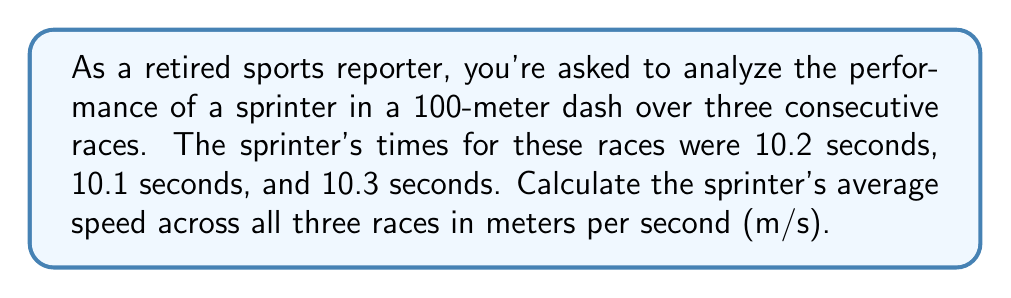What is the answer to this math problem? To solve this problem, we'll follow these steps:

1) First, we need to calculate the speed for each individual race:
   Speed = Distance / Time

   For a 100-meter dash:
   $$\text{Speed} = \frac{100 \text{ meters}}{\text{Time in seconds}}$$

   Race 1: $\frac{100}{10.2} = 9.80$ m/s
   Race 2: $\frac{100}{10.1} = 9.90$ m/s
   Race 3: $\frac{100}{10.3} = 9.71$ m/s

2) Now, to find the average speed, we sum up all the speeds and divide by the number of races:

   $$\text{Average Speed} = \frac{\text{Sum of Speeds}}{\text{Number of Races}}$$

   $$\text{Average Speed} = \frac{9.80 + 9.90 + 9.71}{3}$$

3) Let's perform this calculation:
   $$\text{Average Speed} = \frac{29.41}{3} = 9.80333...$$

4) Rounding to two decimal places:
   Average Speed ≈ 9.80 m/s
Answer: The sprinter's average speed across all three races is approximately 9.80 m/s. 